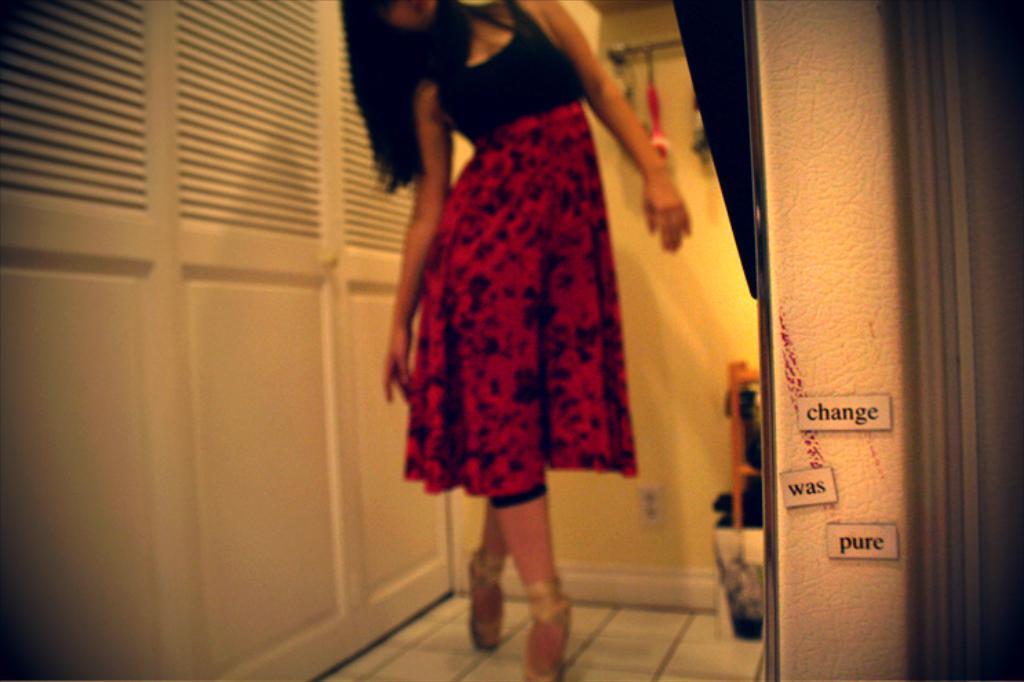Can you describe this image briefly? In the foreground of this picture, there is a woman standing on the tile. On the right, there is a text paper pasted on a wall. In the background, there are cupboards and a wall. 